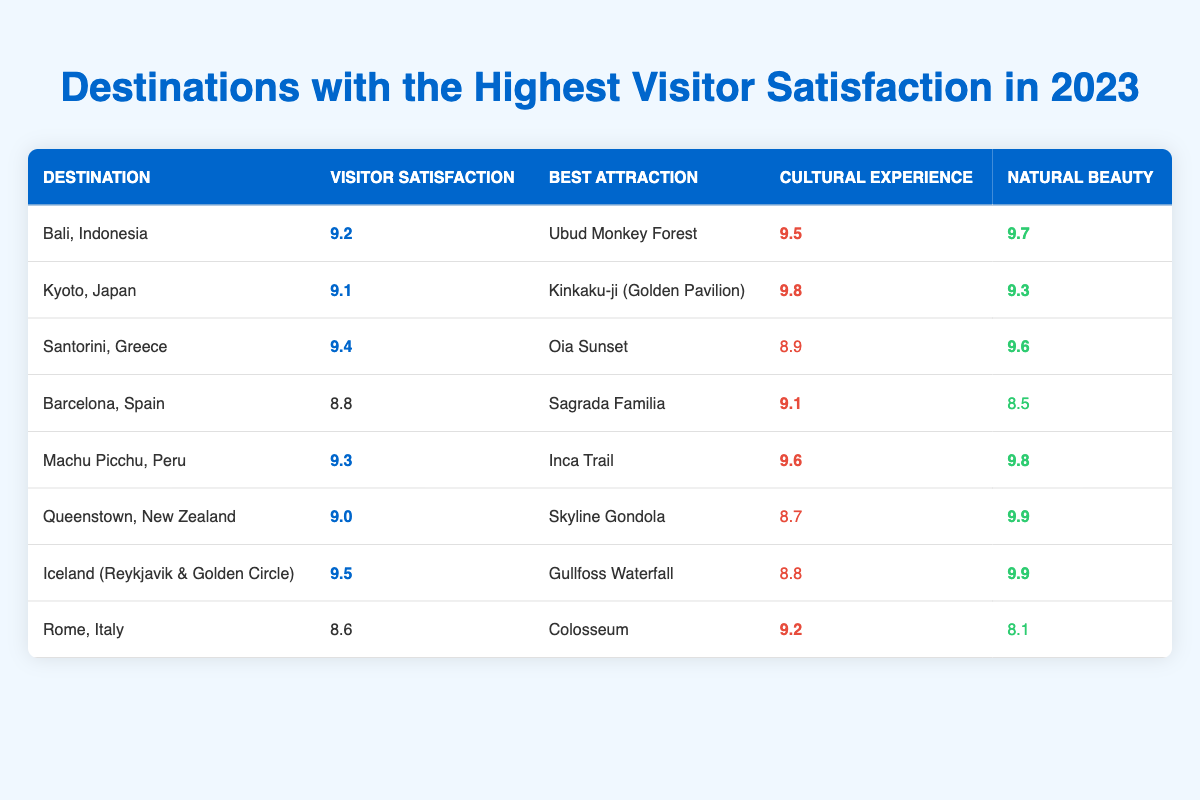What destination has the highest visitor satisfaction rating in 2023? The highest visitor satisfaction rating in the table is 9.5, which corresponds to Iceland (Reykjavik & Golden Circle).
Answer: Iceland (Reykjavik & Golden Circle) What is the visitor satisfaction rating for Kyoto, Japan? Looking at the table, the visitor satisfaction rating for Kyoto, Japan, is 9.1.
Answer: 9.1 Which destination's best attraction is the Oia Sunset? The best attraction listed as the Oia Sunset corresponds to Santorini, Greece, which is the destination.
Answer: Santorini, Greece What is the natural beauty score of Queenstown, New Zealand? The table shows that the natural beauty score for Queenstown, New Zealand, is 9.9.
Answer: 9.9 Which destination has the lowest visitor satisfaction rating? To find the lowest visitor satisfaction rating, we look at the table and see that Rome, Italy has the lowest rating of 8.6.
Answer: Rome, Italy What is the difference between the visitor satisfaction ratings of Santorini and Barcelona? The visitor satisfaction rating for Santorini is 9.4, while for Barcelona it is 8.8. The difference is 9.4 - 8.8 = 0.6.
Answer: 0.6 Is the cultural experience score of Bali higher than that of Barcelona? The cultural experience score for Bali is 9.5, and for Barcelona, it is 9.1. Since 9.5 is greater than 9.1, the statement is true.
Answer: Yes What is the average visitor satisfaction rating of the top three destinations? The top three destinations by visitor satisfaction ratings are Iceland (9.5), Santorini (9.4), and Machu Picchu (9.3). The sum is 9.5 + 9.4 + 9.3 = 28.2, and dividing by 3 gives an average of 28.2 / 3 = 9.4.
Answer: 9.4 What percentage of destinations have a visitor satisfaction rating above 9.0? Counting the destinations, we have 5 with ratings above 9.0 (Bali, Santorini, Iceland, Machu Picchu, and Queenstown) out of 8 total destinations. The percentage is (5/8) * 100 = 62.5%.
Answer: 62.5% Which destination has a cultural experience score of 9.2 or higher? Checking the table, we see that the destinations with a cultural experience score of 9.2 or higher are Bali (9.5), Kyoto (9.8), Machu Picchu (9.6), and Rome (9.2).
Answer: Bali, Kyoto, Machu Picchu, Rome 